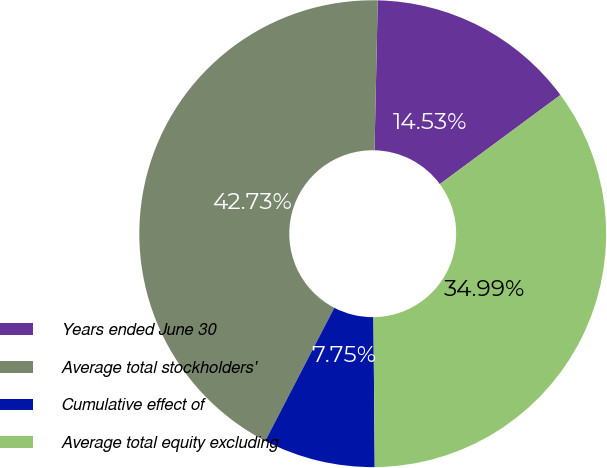<chart> <loc_0><loc_0><loc_500><loc_500><pie_chart><fcel>Years ended June 30<fcel>Average total stockholders'<fcel>Cumulative effect of<fcel>Average total equity excluding<nl><fcel>14.53%<fcel>42.73%<fcel>7.75%<fcel>34.99%<nl></chart> 